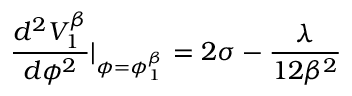Convert formula to latex. <formula><loc_0><loc_0><loc_500><loc_500>\frac { d ^ { 2 } V _ { 1 } ^ { \beta } } { d \phi ^ { 2 } } | _ { \phi = \phi _ { 1 } ^ { \beta } } = 2 \sigma - \frac { \lambda } { 1 2 \beta ^ { 2 } }</formula> 